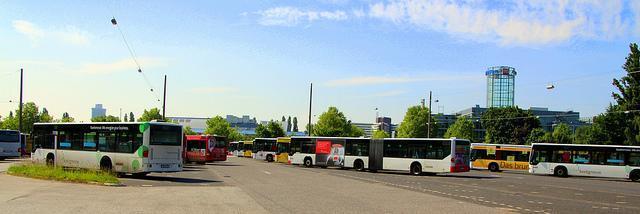How many poles are there?
Give a very brief answer. 4. How many buses are in the picture?
Give a very brief answer. 3. How many people are skiing?
Give a very brief answer. 0. 